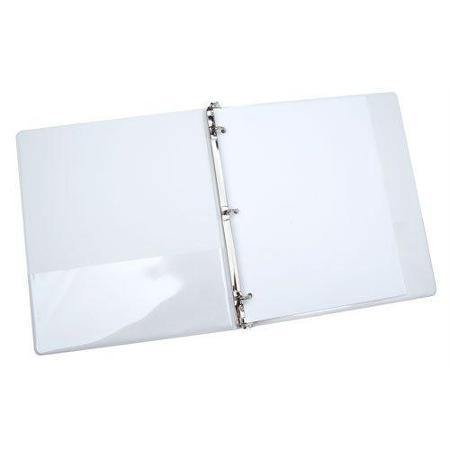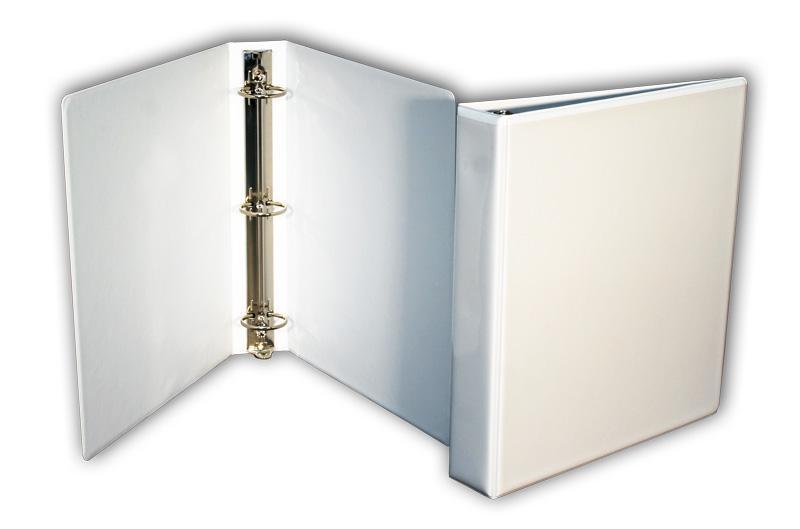The first image is the image on the left, the second image is the image on the right. Evaluate the accuracy of this statement regarding the images: "All images show only black binders.". Is it true? Answer yes or no. No. The first image is the image on the left, the second image is the image on the right. For the images shown, is this caption "Two white notebooks, one open and one closed, are shown in one image, while only one notebook lying flat is in the second image." true? Answer yes or no. Yes. 